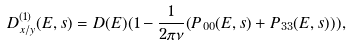Convert formula to latex. <formula><loc_0><loc_0><loc_500><loc_500>D _ { x / y } ^ { ( 1 ) } ( E , s ) = D ( E ) ( 1 - \frac { 1 } { 2 \pi \nu } ( P _ { 0 0 } ( E , s ) + P _ { 3 3 } ( E , s ) ) ) ,</formula> 